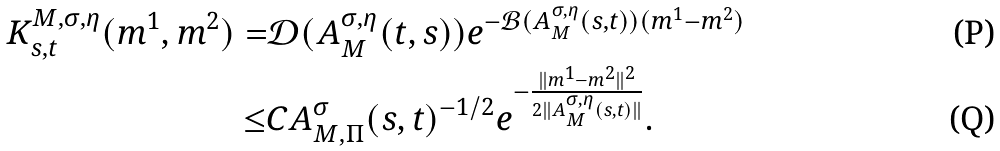<formula> <loc_0><loc_0><loc_500><loc_500>K ^ { M , \sigma , \eta } _ { s , t } ( m ^ { 1 } , m ^ { 2 } ) = & \mathcal { D } ( A ^ { \sigma , \eta } _ { M } ( t , s ) ) e ^ { - \mathcal { B } ( A ^ { \sigma , \eta } _ { M } ( s , t ) ) ( m ^ { 1 } - m ^ { 2 } ) } \\ \leq & C A _ { M , \Pi } ^ { \sigma } ( s , t ) ^ { - 1 \slash 2 } e ^ { - \frac { \| m ^ { 1 } - m ^ { 2 } \| ^ { 2 } } { 2 \| A ^ { \sigma , \eta } _ { M } ( s , t ) \| } } .</formula> 